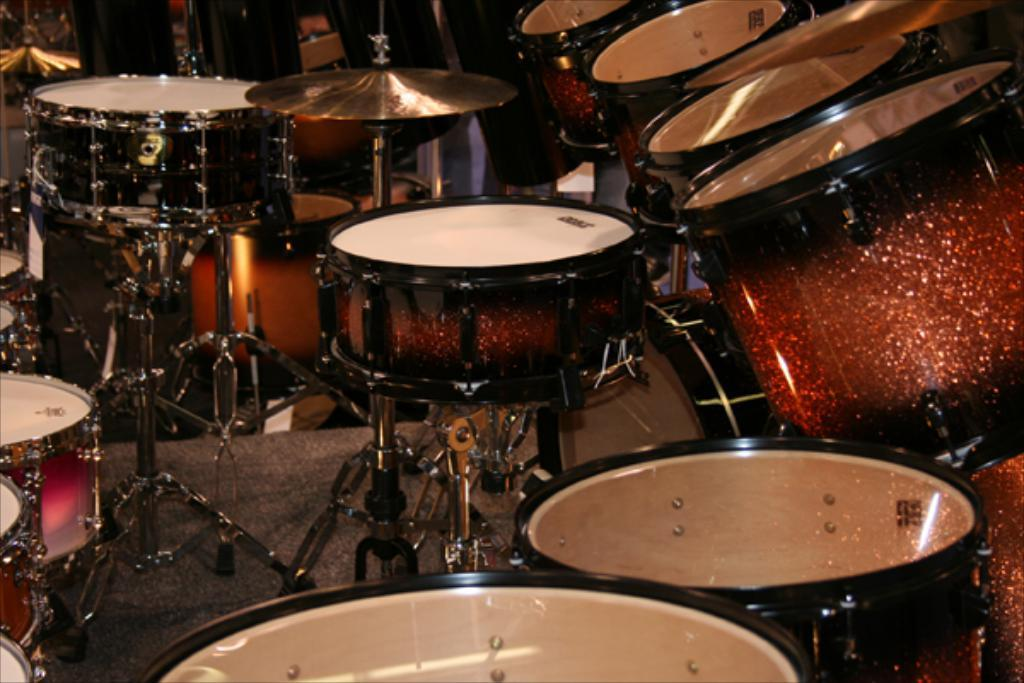What type of objects can be seen in the image? There are musical instruments in the image. Can you describe the colors of the musical instruments? The musical instruments are in white, black, and brown colors. How many pictures are hanging on the wall in the image? There is no mention of any pictures hanging on the wall in the image; the facts only mention musical instruments. 